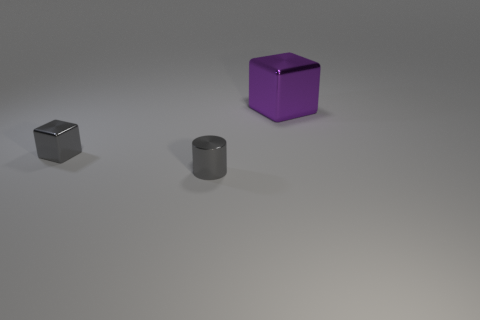How many other objects are the same color as the tiny metallic block?
Offer a terse response. 1. Are there more large purple blocks that are on the right side of the purple cube than large red cylinders?
Your answer should be compact. No. Do the big block and the small cube have the same material?
Give a very brief answer. Yes. How many things are shiny blocks that are in front of the purple metallic thing or big cyan matte cylinders?
Ensure brevity in your answer.  1. How many other objects are the same size as the cylinder?
Keep it short and to the point. 1. Are there the same number of gray metal cylinders behind the small gray cylinder and metal things on the right side of the purple metal block?
Your answer should be very brief. Yes. There is another metal thing that is the same shape as the large metal thing; what color is it?
Your response must be concise. Gray. Is there any other thing that is the same shape as the purple object?
Offer a very short reply. Yes. There is a metallic block in front of the large metallic thing; does it have the same color as the big shiny thing?
Provide a succinct answer. No. What size is the other gray metal object that is the same shape as the large object?
Ensure brevity in your answer.  Small. 